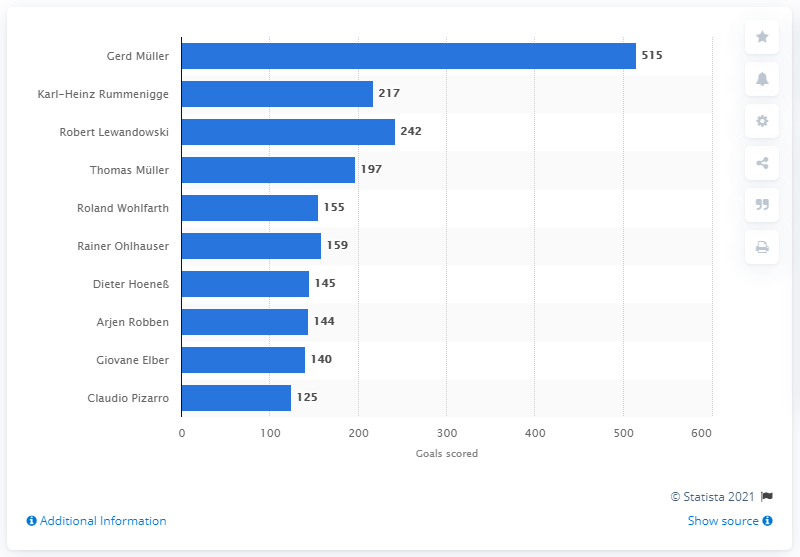Point out several critical features in this image. Gerd M14ller has scored 515 goals for Bayern Munich. 